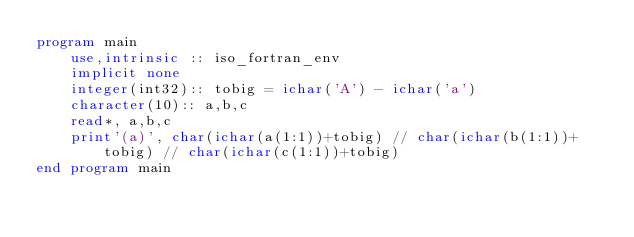<code> <loc_0><loc_0><loc_500><loc_500><_FORTRAN_>program main
    use,intrinsic :: iso_fortran_env
    implicit none
    integer(int32):: tobig = ichar('A') - ichar('a')
    character(10):: a,b,c
    read*, a,b,c
    print'(a)', char(ichar(a(1:1))+tobig) // char(ichar(b(1:1))+tobig) // char(ichar(c(1:1))+tobig)
end program main</code> 